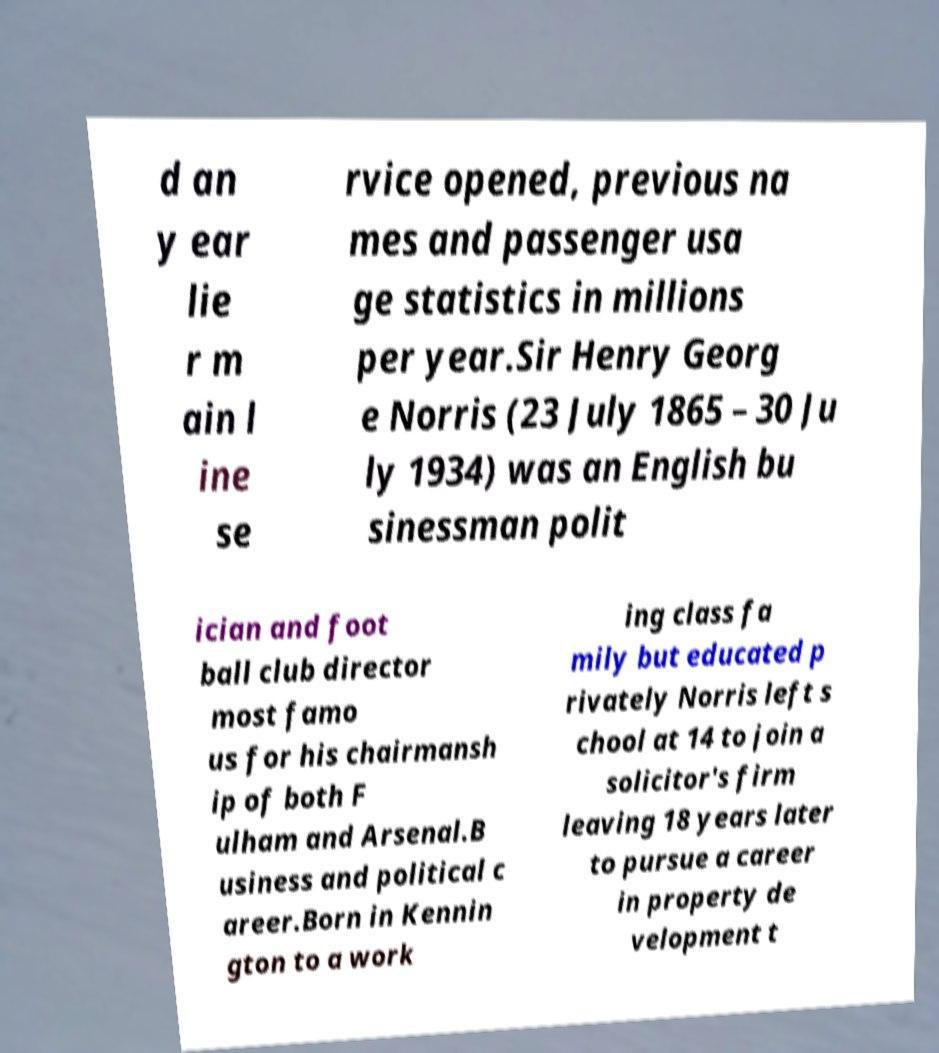Can you read and provide the text displayed in the image?This photo seems to have some interesting text. Can you extract and type it out for me? d an y ear lie r m ain l ine se rvice opened, previous na mes and passenger usa ge statistics in millions per year.Sir Henry Georg e Norris (23 July 1865 – 30 Ju ly 1934) was an English bu sinessman polit ician and foot ball club director most famo us for his chairmansh ip of both F ulham and Arsenal.B usiness and political c areer.Born in Kennin gton to a work ing class fa mily but educated p rivately Norris left s chool at 14 to join a solicitor's firm leaving 18 years later to pursue a career in property de velopment t 